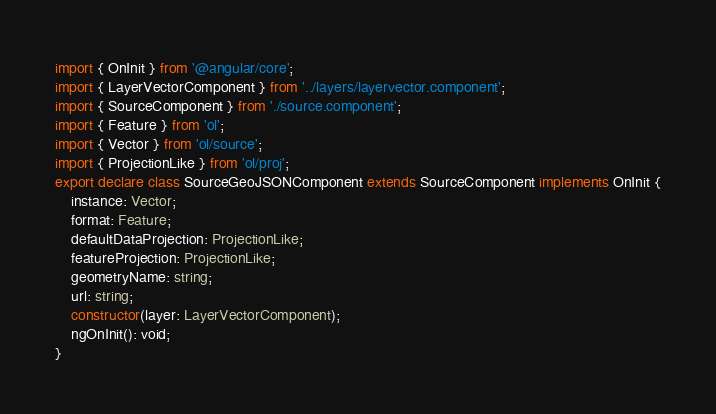<code> <loc_0><loc_0><loc_500><loc_500><_TypeScript_>import { OnInit } from '@angular/core';
import { LayerVectorComponent } from '../layers/layervector.component';
import { SourceComponent } from './source.component';
import { Feature } from 'ol';
import { Vector } from 'ol/source';
import { ProjectionLike } from 'ol/proj';
export declare class SourceGeoJSONComponent extends SourceComponent implements OnInit {
    instance: Vector;
    format: Feature;
    defaultDataProjection: ProjectionLike;
    featureProjection: ProjectionLike;
    geometryName: string;
    url: string;
    constructor(layer: LayerVectorComponent);
    ngOnInit(): void;
}
</code> 